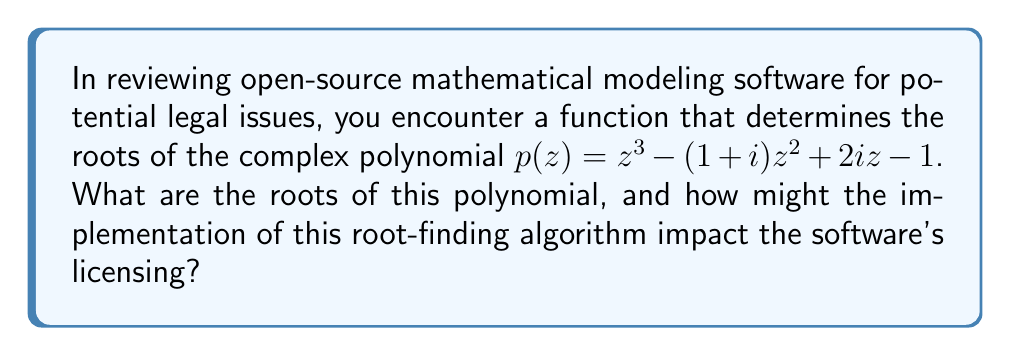Could you help me with this problem? To find the roots of the complex polynomial $p(z) = z^3 - (1+i)z^2 + 2iz - 1$, we can use the following steps:

1. Identify the coefficients:
   $a = 1$
   $b = -(1+i)$
   $c = 2i$
   $d = -1$

2. Calculate the intermediate values:
   $p = -\frac{b^2}{3a^2} + \frac{c}{a} = -\frac{(-(1+i))^2}{3(1)^2} + \frac{2i}{1} = -\frac{-2-2i}{3} + 2i = \frac{2}{3} + \frac{4}{3}i$
   
   $q = \frac{2b^3}{27a^3} - \frac{bc}{3a^2} + \frac{d}{a} = \frac{2(-(1+i))^3}{27} - \frac{(-(1+i))(2i)}{3} - 1$
      $= -\frac{2(-1-3i-3i+i)}{27} + \frac{2+2i}{3} - 1$
      $= \frac{2+6i}{27} + \frac{2+2i}{3} - 1$
      $= \frac{2}{27} + \frac{2}{9}i + \frac{2}{3} + \frac{2}{3}i - 1$
      $= -\frac{7}{27} + \frac{20}{9}i$

3. Calculate the discriminant:
   $D = (\frac{q}{2})^2 + (\frac{p}{3})^3$
   $= (\frac{-7/27 + 20i/9}{2})^2 + (\frac{2/3 + 4i/3}{3})^3$
   $\approx -0.0052 - 0.0008i$ (approximate value)

4. Since $D \neq 0$, the polynomial has three distinct roots. We can find them using the cubic formula:

   $z_k = -\frac{b}{3a} + \sqrt[3]{-\frac{q}{2} + \sqrt{D}} + \sqrt[3]{-\frac{q}{2} - \sqrt{D}}$

   Where $k = 0, 1, 2$ and the cube roots are chosen such that their product is $-p/3$.

5. Calculating the roots (approximate values):
   $z_1 \approx 1.4665 + 0.8480i$
   $z_2 \approx -0.6793 + 0.3371i$
   $z_3 \approx 0.2128 - 0.1851i$

Regarding the implementation's impact on licensing:
The root-finding algorithm used in the software could affect licensing if it incorporates patented methods or code from libraries with restrictive licenses. It's crucial to review the specific implementation and any third-party libraries used to ensure compliance with open-source licensing terms and avoid potential patent infringement.
Answer: $z_1 \approx 1.4665 + 0.8480i$, $z_2 \approx -0.6793 + 0.3371i$, $z_3 \approx 0.2128 - 0.1851i$. Licensing impact depends on the specific implementation and third-party libraries used. 